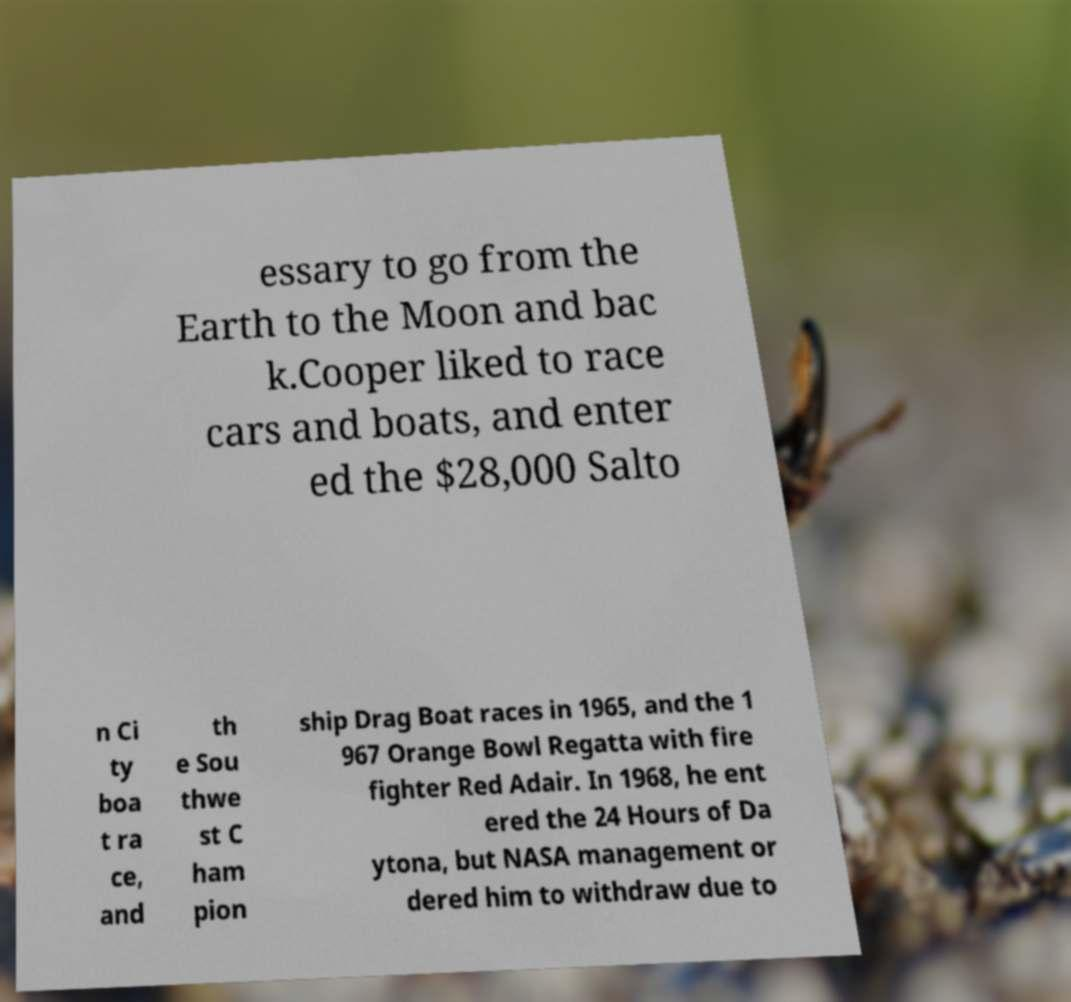Could you assist in decoding the text presented in this image and type it out clearly? essary to go from the Earth to the Moon and bac k.Cooper liked to race cars and boats, and enter ed the $28,000 Salto n Ci ty boa t ra ce, and th e Sou thwe st C ham pion ship Drag Boat races in 1965, and the 1 967 Orange Bowl Regatta with fire fighter Red Adair. In 1968, he ent ered the 24 Hours of Da ytona, but NASA management or dered him to withdraw due to 